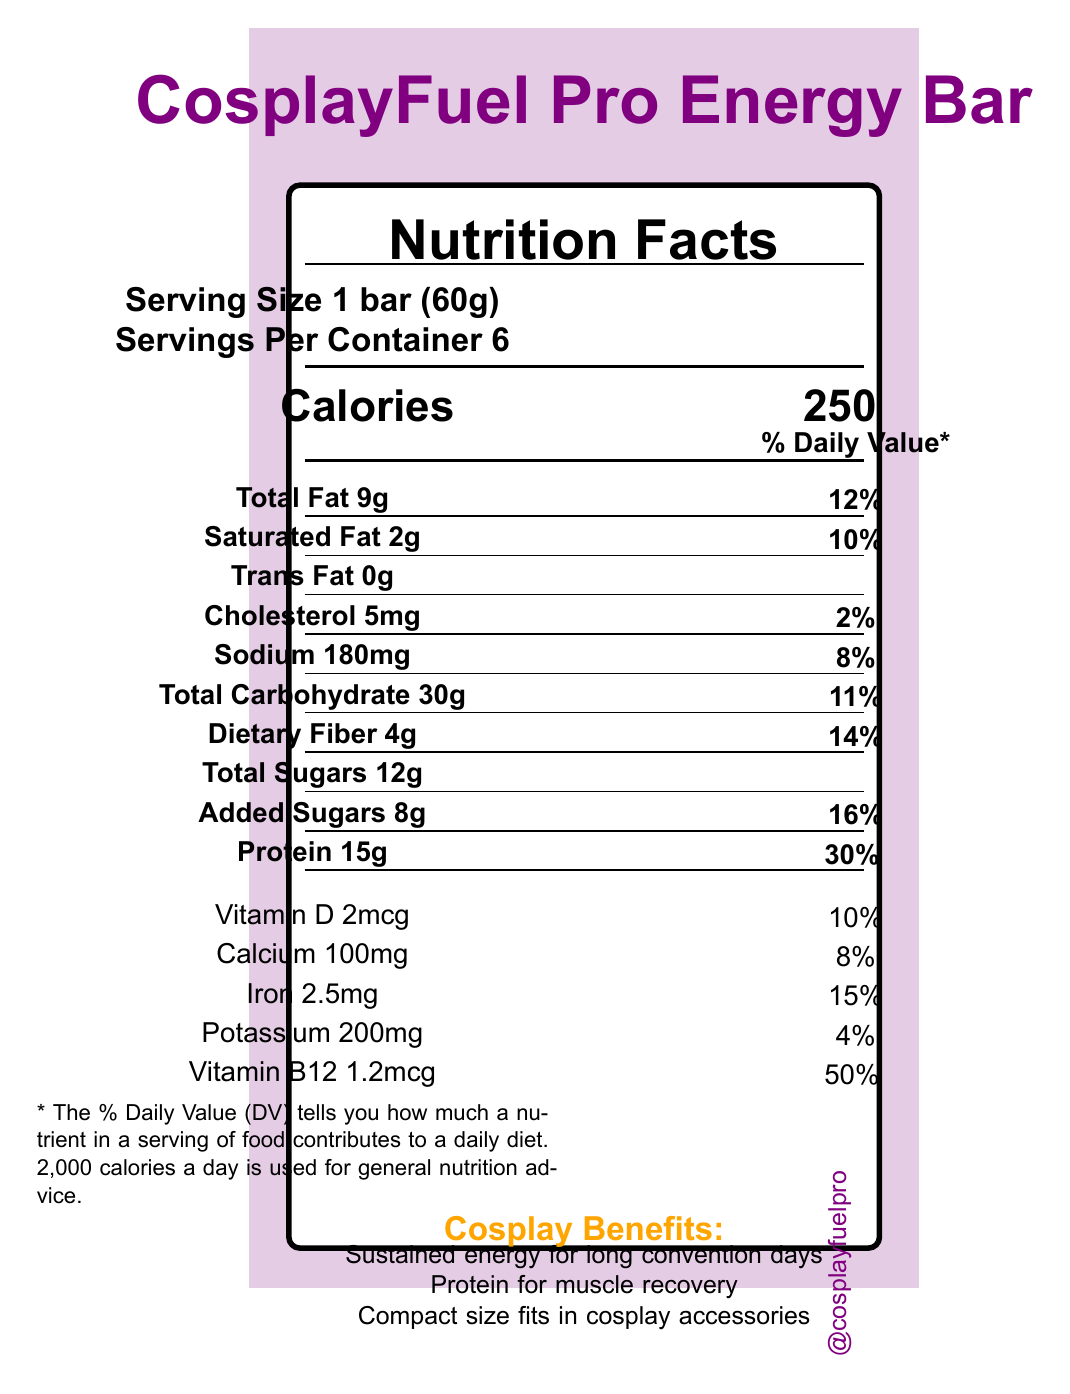what is the serving size? The serving size is specified as "1 bar (60g)" in the document.
Answer: 1 bar (60g) how many calories are in one serving? The calories per serving are listed as 250.
Answer: 250 what is the total fat content per serving? The total fat content per serving is listed as 9g.
Answer: 9g how much protein is in one bar? The protein content per serving is listed as 15g.
Answer: 15g what are the first two ingredients listed? The first two ingredients listed are "Whey protein isolate" and "Almond butter".
Answer: Whey protein isolate, Almond butter how much dietary fiber does the energy bar contain per serving? The dietary fiber content per serving is listed as 4g.
Answer: 4g what percent of the daily value for calcium does one bar provide? The daily value percentage for calcium per serving is listed as 8%.
Answer: 8% which vitamin is present in the highest daily value percentage? A. Vitamin D B. Calcium C. Iron D. Vitamin B12 Vitamin B12 has the highest daily value percentage at 50%.
Answer: D how many servings are there in one container? The document specifies that there are 6 servings per container.
Answer: 6 how much cholesterol is in one serving of the energy bar? The cholesterol content per serving is listed as 5mg.
Answer: 5mg does the bar contain any trans fat? The document states that the trans fat content is 0g.
Answer: No what are some of the cosplay benefits mentioned for the energy bar? The cosplay benefits listed include sustained energy for long convention days, protein for muscle recovery, and a compact size that fits in cosplay accessories.
Answer: Sustained energy for long convention days, Protein for muscle recovery, Compact size fits in cosplay accessories is this product convention tested? The document confirms that the product is convention tested.
Answer: Yes what is the total carbohydrate content per serving? The total carbohydrate content per serving is listed as 30g.
Answer: 30g can you determine which is the main ingredient in the bar? The document lists the ingredients but does not specify which is the main ingredient.
Answer: Not enough information summarize the main idea of the document. The main points from the document include the detailed nutrition facts per serving, the listed ingredients with allergen information, and the specific benefits tailored for cosplayers, along with social media handles.
Answer: The document provides the nutritional information, ingredients, allergen info, and benefits of the CosplayFuel Pro Energy Bar, which is designed for cosplayers to provide them with energy and muscle recovery during conventions. 